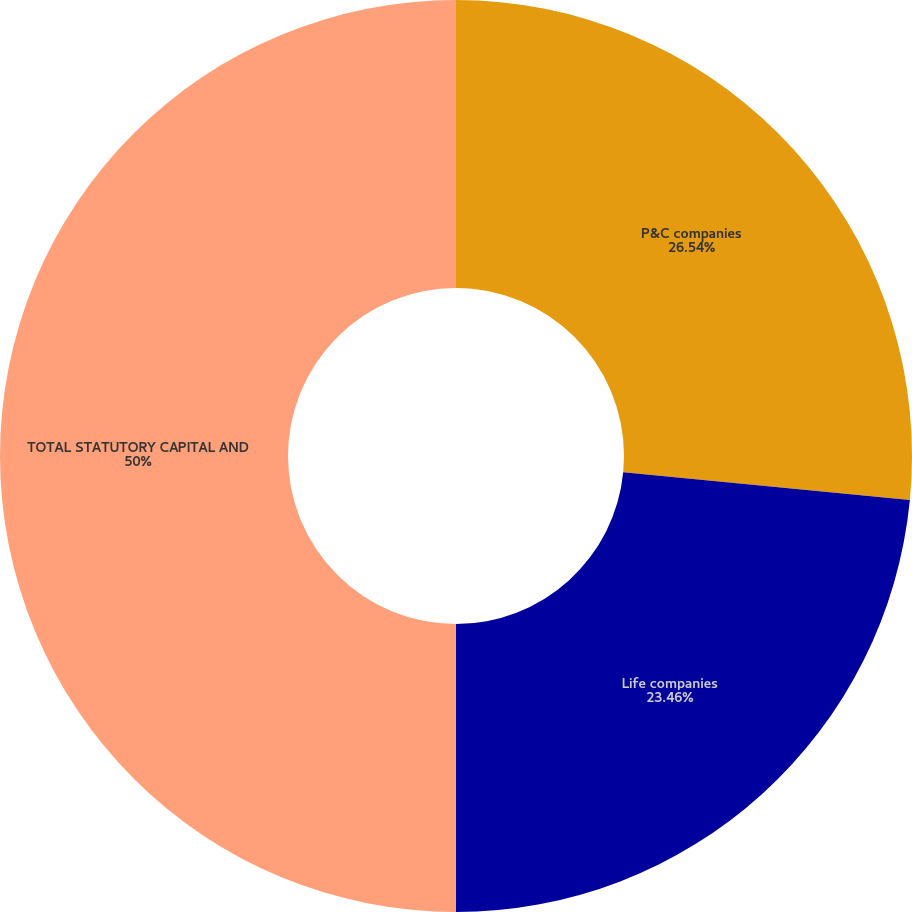<chart> <loc_0><loc_0><loc_500><loc_500><pie_chart><fcel>P&C companies<fcel>Life companies<fcel>TOTAL STATUTORY CAPITAL AND<nl><fcel>26.54%<fcel>23.46%<fcel>50.0%<nl></chart> 